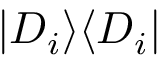Convert formula to latex. <formula><loc_0><loc_0><loc_500><loc_500>| D _ { i } \rangle \langle D _ { i } |</formula> 